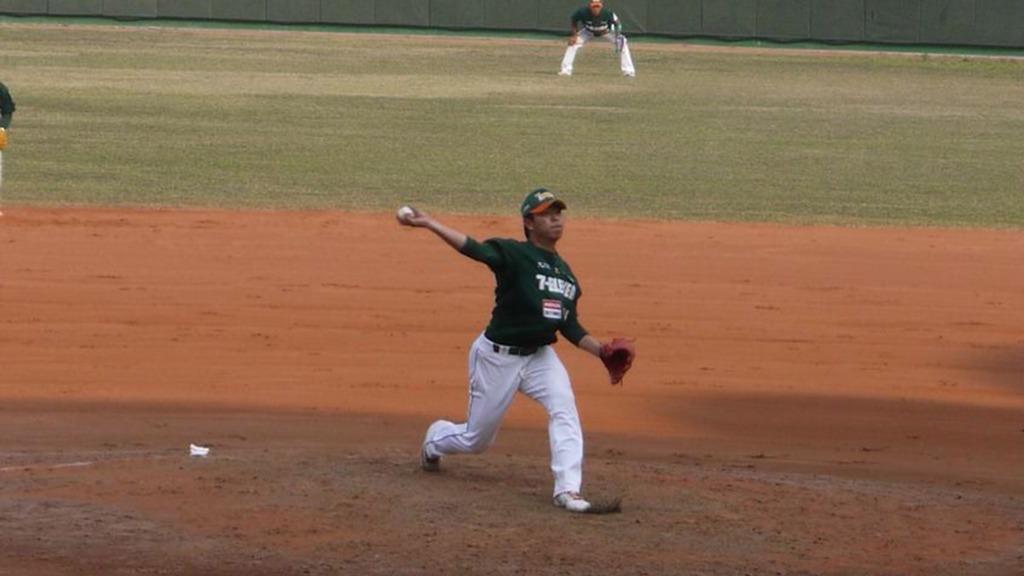How would you summarize this image in a sentence or two? In this picture we can see few people, they are playing game in the ground, in the middle of the image we can see a man he is holding a ball, and he wore a cap. 